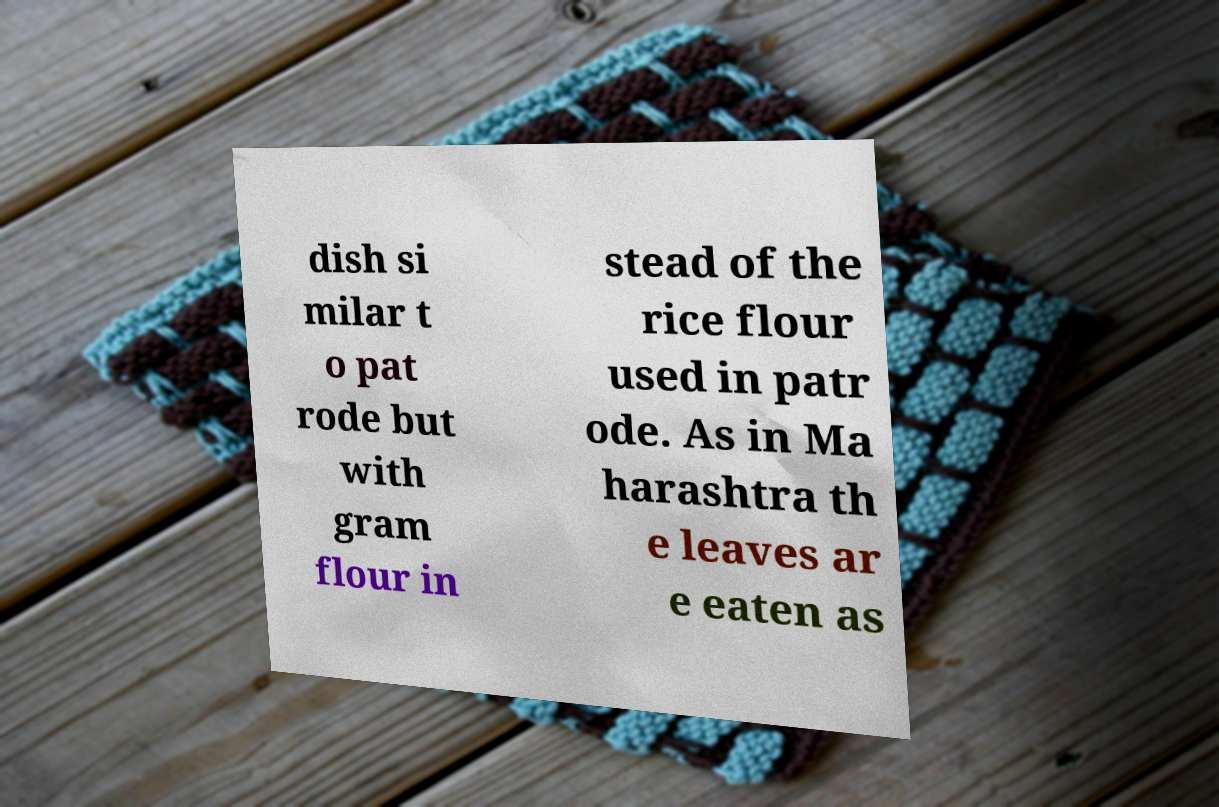Can you read and provide the text displayed in the image?This photo seems to have some interesting text. Can you extract and type it out for me? dish si milar t o pat rode but with gram flour in stead of the rice flour used in patr ode. As in Ma harashtra th e leaves ar e eaten as 